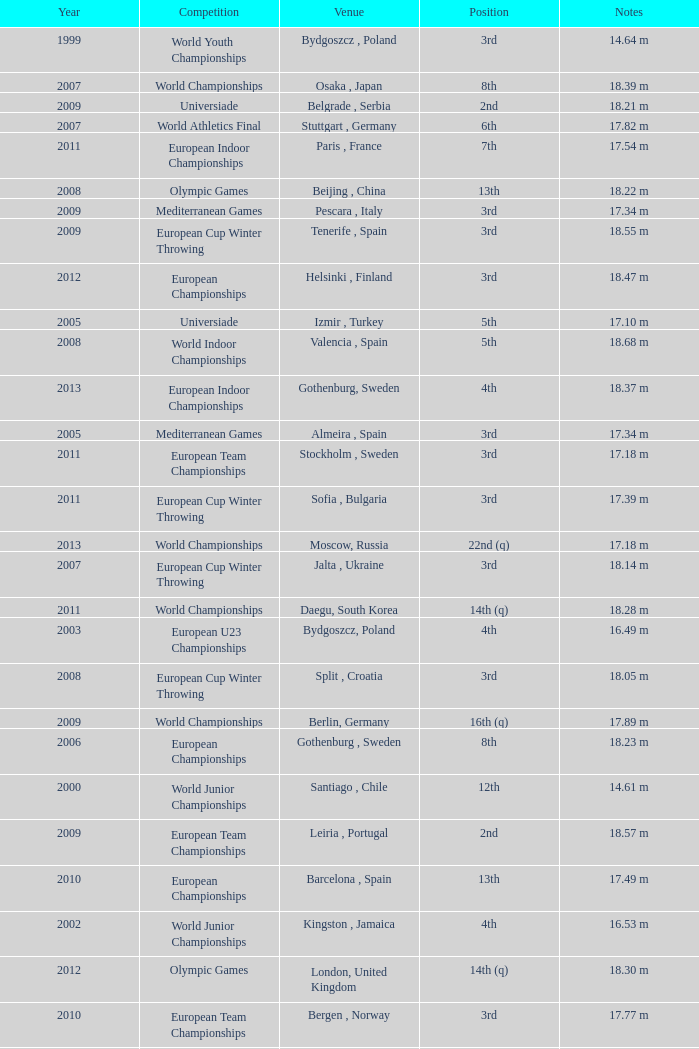Where were the Mediterranean games after 2005? Pescara , Italy. Could you parse the entire table as a dict? {'header': ['Year', 'Competition', 'Venue', 'Position', 'Notes'], 'rows': [['1999', 'World Youth Championships', 'Bydgoszcz , Poland', '3rd', '14.64 m'], ['2007', 'World Championships', 'Osaka , Japan', '8th', '18.39 m'], ['2009', 'Universiade', 'Belgrade , Serbia', '2nd', '18.21 m'], ['2007', 'World Athletics Final', 'Stuttgart , Germany', '6th', '17.82 m'], ['2011', 'European Indoor Championships', 'Paris , France', '7th', '17.54 m'], ['2008', 'Olympic Games', 'Beijing , China', '13th', '18.22 m'], ['2009', 'Mediterranean Games', 'Pescara , Italy', '3rd', '17.34 m'], ['2009', 'European Cup Winter Throwing', 'Tenerife , Spain', '3rd', '18.55 m'], ['2012', 'European Championships', 'Helsinki , Finland', '3rd', '18.47 m'], ['2005', 'Universiade', 'Izmir , Turkey', '5th', '17.10 m'], ['2008', 'World Indoor Championships', 'Valencia , Spain', '5th', '18.68 m'], ['2013', 'European Indoor Championships', 'Gothenburg, Sweden', '4th', '18.37 m'], ['2005', 'Mediterranean Games', 'Almeira , Spain', '3rd', '17.34 m'], ['2011', 'European Team Championships', 'Stockholm , Sweden', '3rd', '17.18 m'], ['2011', 'European Cup Winter Throwing', 'Sofia , Bulgaria', '3rd', '17.39 m'], ['2013', 'World Championships', 'Moscow, Russia', '22nd (q)', '17.18 m'], ['2007', 'European Cup Winter Throwing', 'Jalta , Ukraine', '3rd', '18.14 m'], ['2011', 'World Championships', 'Daegu, South Korea', '14th (q)', '18.28 m'], ['2003', 'European U23 Championships', 'Bydgoszcz, Poland', '4th', '16.49 m'], ['2008', 'European Cup Winter Throwing', 'Split , Croatia', '3rd', '18.05 m'], ['2009', 'World Championships', 'Berlin, Germany', '16th (q)', '17.89 m'], ['2006', 'European Championships', 'Gothenburg , Sweden', '8th', '18.23 m'], ['2000', 'World Junior Championships', 'Santiago , Chile', '12th', '14.61 m'], ['2009', 'European Team Championships', 'Leiria , Portugal', '2nd', '18.57 m'], ['2010', 'European Championships', 'Barcelona , Spain', '13th', '17.49 m'], ['2002', 'World Junior Championships', 'Kingston , Jamaica', '4th', '16.53 m'], ['2012', 'Olympic Games', 'London, United Kingdom', '14th (q)', '18.30 m'], ['2010', 'European Team Championships', 'Bergen , Norway', '3rd', '17.77 m'], ['2005', 'European U23 Championships', 'Erfurt , Germany', '3rd', '18.22 m']]} 